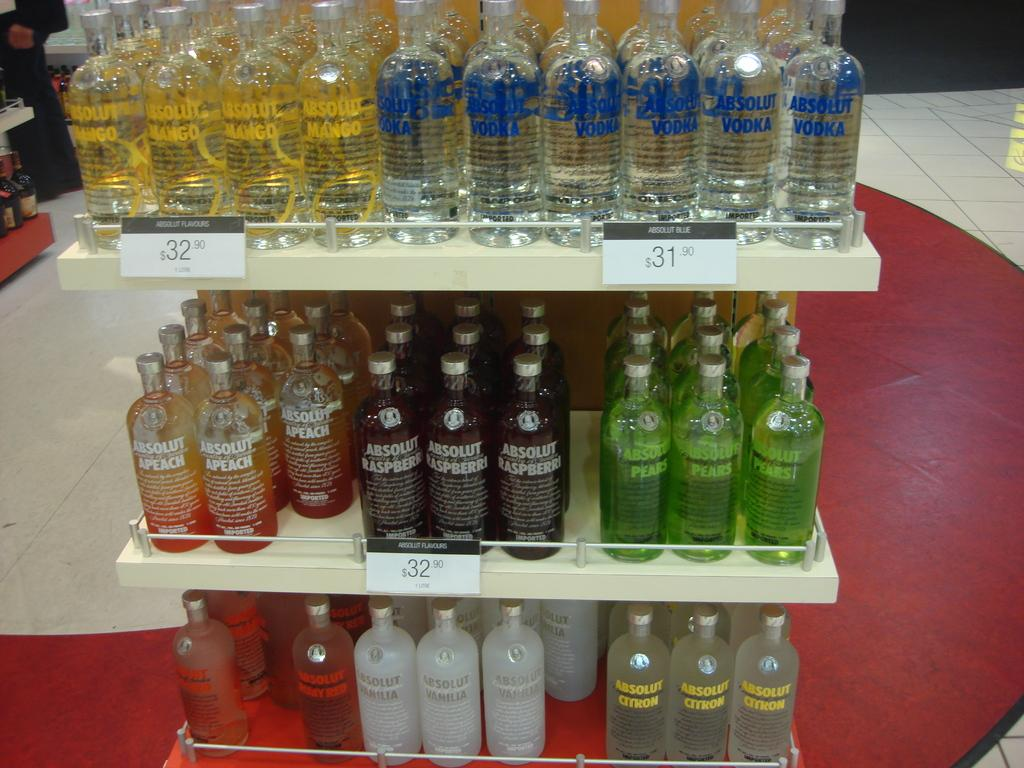Provide a one-sentence caption for the provided image. Absolute vodka on a special offer in a store. 